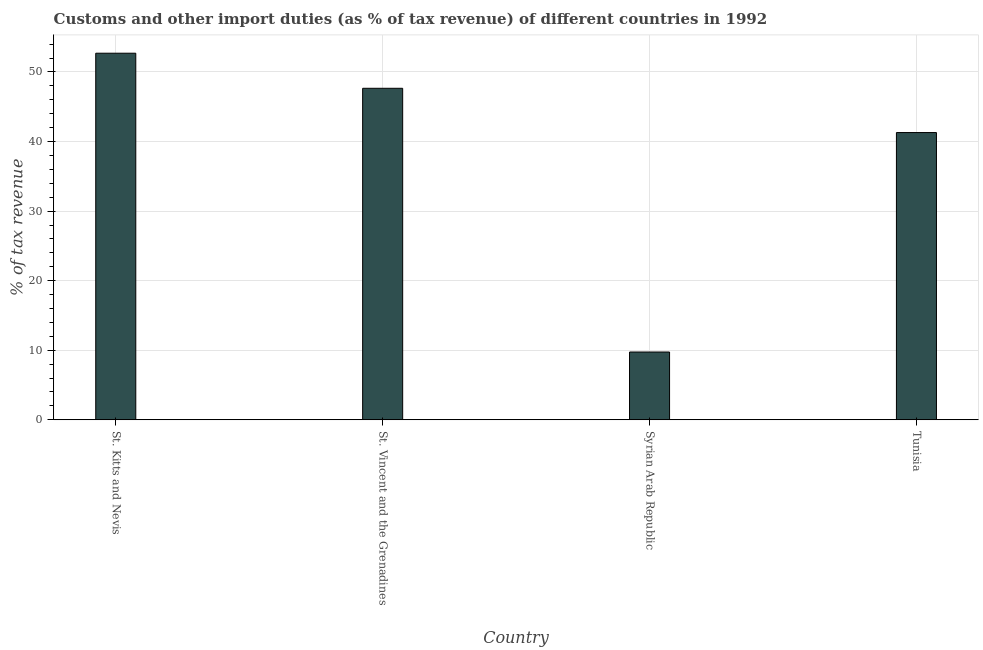Does the graph contain grids?
Keep it short and to the point. Yes. What is the title of the graph?
Your response must be concise. Customs and other import duties (as % of tax revenue) of different countries in 1992. What is the label or title of the Y-axis?
Keep it short and to the point. % of tax revenue. What is the customs and other import duties in Syrian Arab Republic?
Give a very brief answer. 9.75. Across all countries, what is the maximum customs and other import duties?
Your response must be concise. 52.7. Across all countries, what is the minimum customs and other import duties?
Keep it short and to the point. 9.75. In which country was the customs and other import duties maximum?
Make the answer very short. St. Kitts and Nevis. In which country was the customs and other import duties minimum?
Your answer should be compact. Syrian Arab Republic. What is the sum of the customs and other import duties?
Ensure brevity in your answer.  151.4. What is the difference between the customs and other import duties in St. Kitts and Nevis and Tunisia?
Your answer should be very brief. 11.41. What is the average customs and other import duties per country?
Offer a very short reply. 37.85. What is the median customs and other import duties?
Your answer should be compact. 44.48. In how many countries, is the customs and other import duties greater than 12 %?
Your answer should be very brief. 3. What is the ratio of the customs and other import duties in Syrian Arab Republic to that in Tunisia?
Your answer should be compact. 0.24. What is the difference between the highest and the second highest customs and other import duties?
Offer a terse response. 5.04. Is the sum of the customs and other import duties in St. Vincent and the Grenadines and Tunisia greater than the maximum customs and other import duties across all countries?
Your response must be concise. Yes. What is the difference between the highest and the lowest customs and other import duties?
Give a very brief answer. 42.95. In how many countries, is the customs and other import duties greater than the average customs and other import duties taken over all countries?
Give a very brief answer. 3. How many bars are there?
Offer a terse response. 4. What is the difference between two consecutive major ticks on the Y-axis?
Provide a short and direct response. 10. Are the values on the major ticks of Y-axis written in scientific E-notation?
Provide a short and direct response. No. What is the % of tax revenue in St. Kitts and Nevis?
Provide a short and direct response. 52.7. What is the % of tax revenue of St. Vincent and the Grenadines?
Keep it short and to the point. 47.66. What is the % of tax revenue in Syrian Arab Republic?
Offer a very short reply. 9.75. What is the % of tax revenue of Tunisia?
Offer a terse response. 41.29. What is the difference between the % of tax revenue in St. Kitts and Nevis and St. Vincent and the Grenadines?
Provide a succinct answer. 5.04. What is the difference between the % of tax revenue in St. Kitts and Nevis and Syrian Arab Republic?
Provide a short and direct response. 42.95. What is the difference between the % of tax revenue in St. Kitts and Nevis and Tunisia?
Your answer should be very brief. 11.41. What is the difference between the % of tax revenue in St. Vincent and the Grenadines and Syrian Arab Republic?
Your response must be concise. 37.91. What is the difference between the % of tax revenue in St. Vincent and the Grenadines and Tunisia?
Provide a short and direct response. 6.36. What is the difference between the % of tax revenue in Syrian Arab Republic and Tunisia?
Offer a very short reply. -31.55. What is the ratio of the % of tax revenue in St. Kitts and Nevis to that in St. Vincent and the Grenadines?
Provide a short and direct response. 1.11. What is the ratio of the % of tax revenue in St. Kitts and Nevis to that in Syrian Arab Republic?
Your response must be concise. 5.41. What is the ratio of the % of tax revenue in St. Kitts and Nevis to that in Tunisia?
Ensure brevity in your answer.  1.28. What is the ratio of the % of tax revenue in St. Vincent and the Grenadines to that in Syrian Arab Republic?
Your response must be concise. 4.89. What is the ratio of the % of tax revenue in St. Vincent and the Grenadines to that in Tunisia?
Keep it short and to the point. 1.15. What is the ratio of the % of tax revenue in Syrian Arab Republic to that in Tunisia?
Your response must be concise. 0.24. 